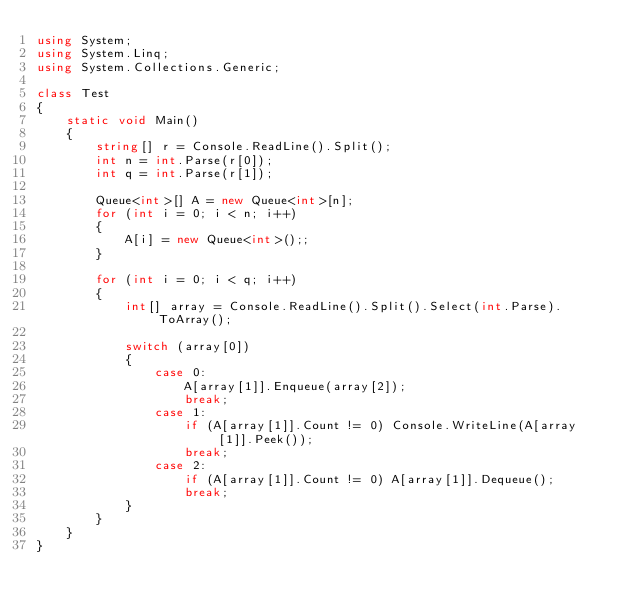<code> <loc_0><loc_0><loc_500><loc_500><_C#_>using System;
using System.Linq;
using System.Collections.Generic;

class Test
{
    static void Main()
    {
        string[] r = Console.ReadLine().Split();
        int n = int.Parse(r[0]);
        int q = int.Parse(r[1]);

        Queue<int>[] A = new Queue<int>[n];
        for (int i = 0; i < n; i++)
        {
            A[i] = new Queue<int>();;
        }

        for (int i = 0; i < q; i++)
        {
            int[] array = Console.ReadLine().Split().Select(int.Parse).ToArray();

            switch (array[0])
            {
                case 0:
                    A[array[1]].Enqueue(array[2]);
                    break;
                case 1:
                    if (A[array[1]].Count != 0) Console.WriteLine(A[array[1]].Peek());
                    break;
                case 2:
                    if (A[array[1]].Count != 0) A[array[1]].Dequeue();
                    break;
            }
        }
    }
}

</code> 